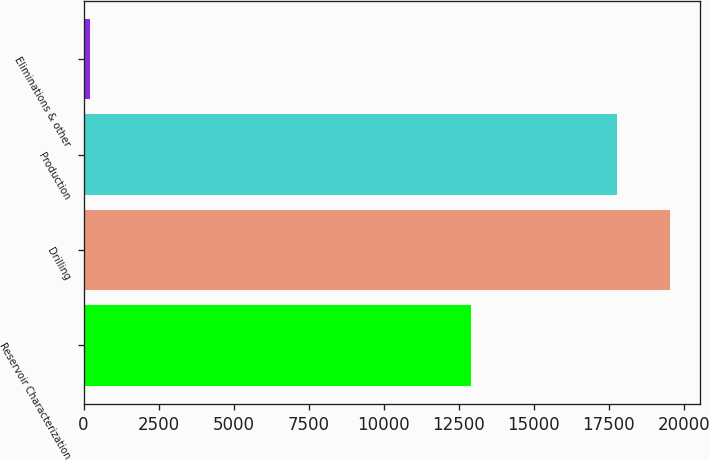Convert chart. <chart><loc_0><loc_0><loc_500><loc_500><bar_chart><fcel>Reservoir Characterization<fcel>Drilling<fcel>Production<fcel>Eliminations & other<nl><fcel>12905<fcel>19554.2<fcel>17763<fcel>216<nl></chart> 